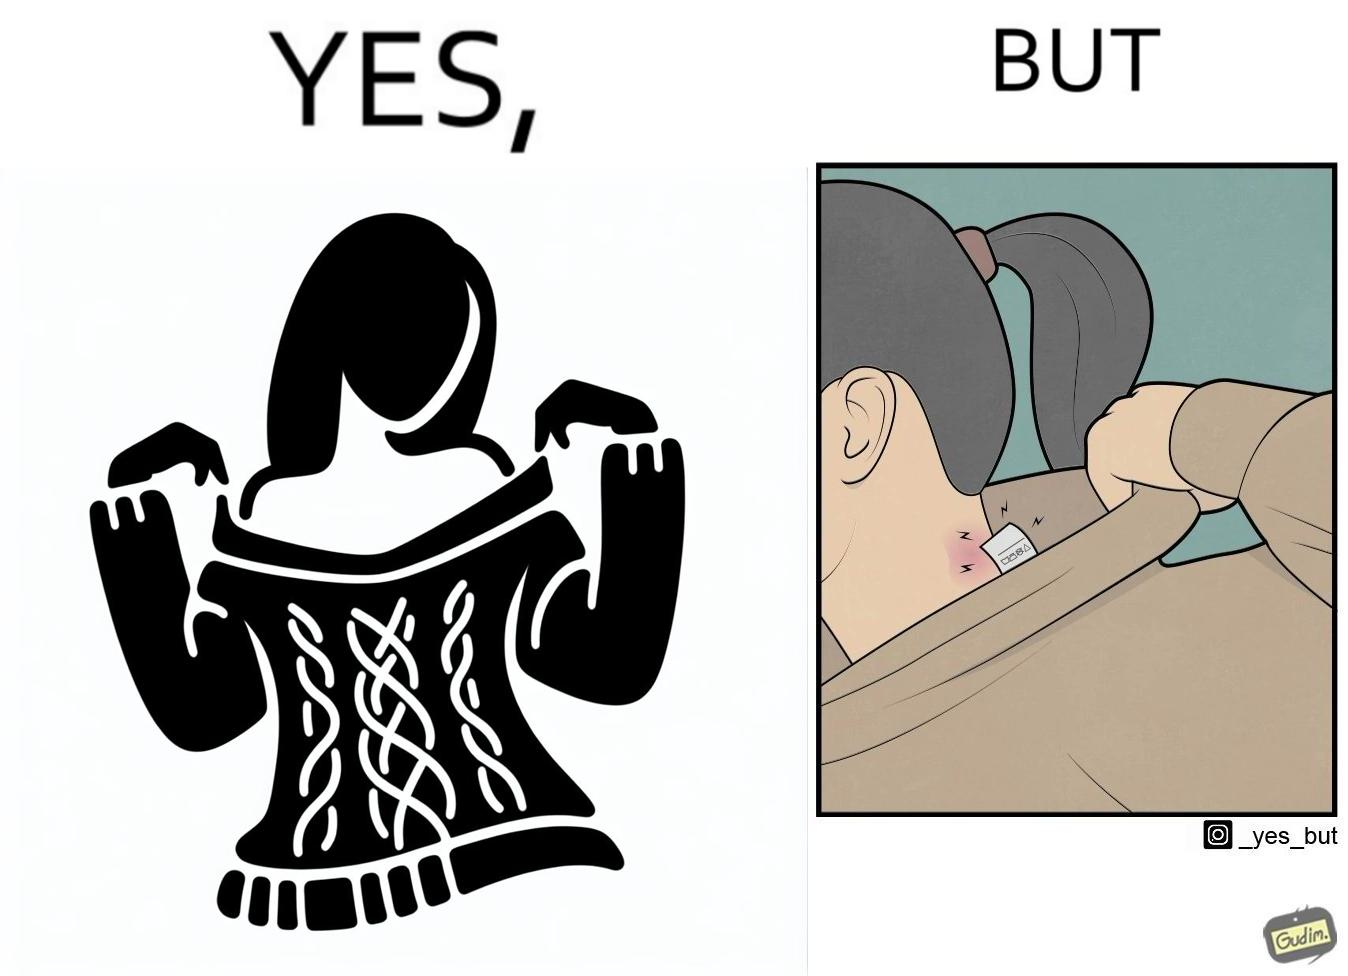Explain why this image is satirical. The images are funny since it shows how even though sweaters and other clothings provide much comfort, a tiny manufacturers tag ends up causing the user a lot of discomfort due to constant scratching 